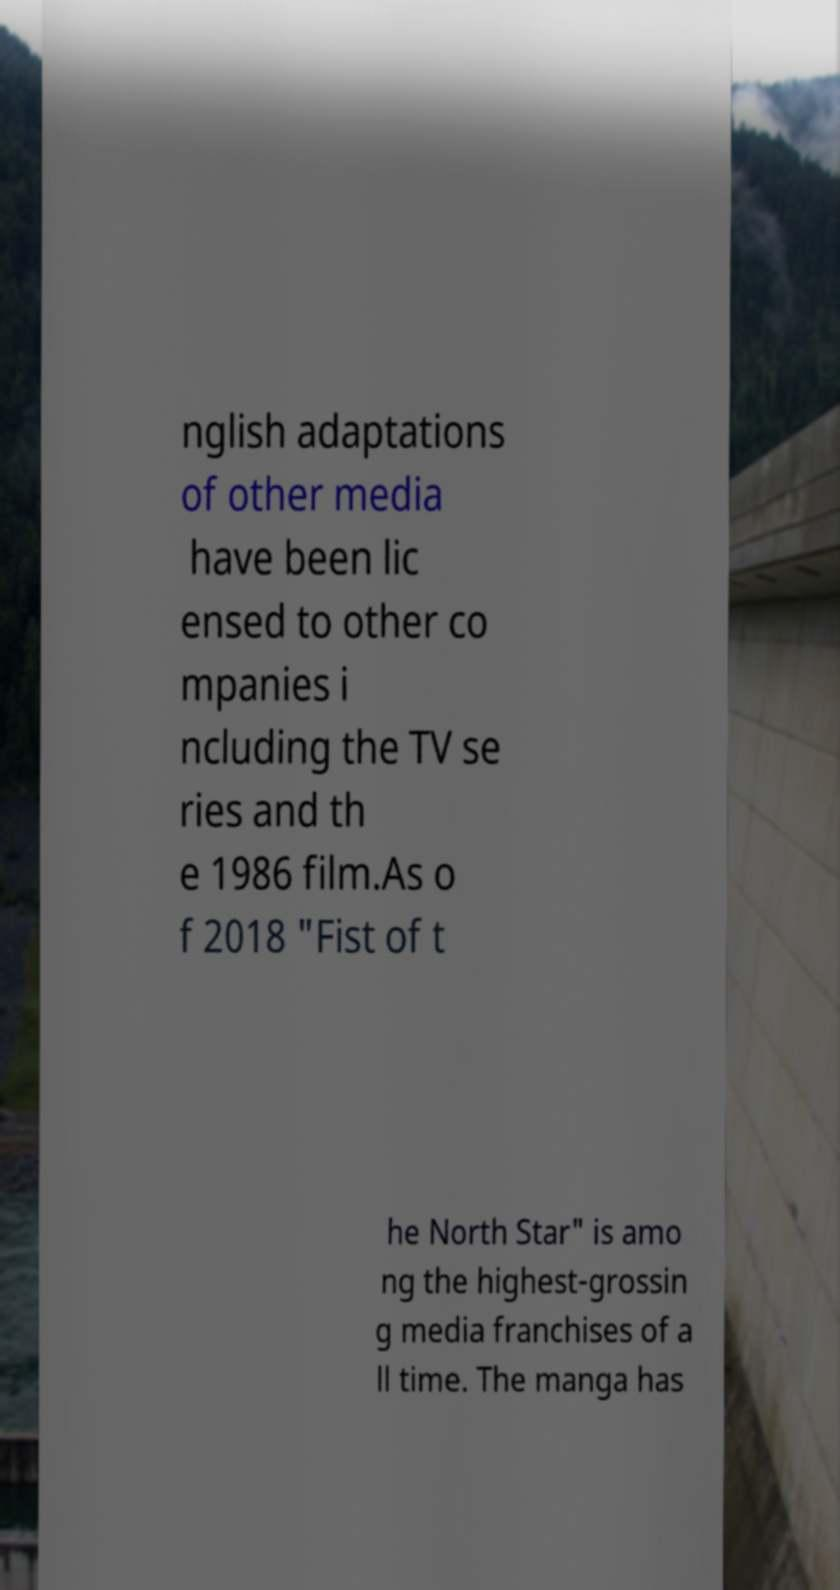Could you extract and type out the text from this image? nglish adaptations of other media have been lic ensed to other co mpanies i ncluding the TV se ries and th e 1986 film.As o f 2018 "Fist of t he North Star" is amo ng the highest-grossin g media franchises of a ll time. The manga has 